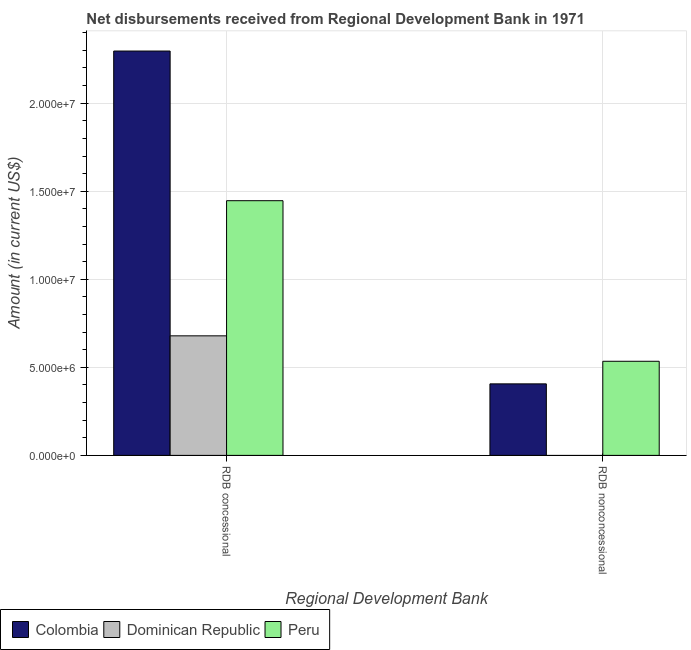How many groups of bars are there?
Your answer should be very brief. 2. Are the number of bars per tick equal to the number of legend labels?
Your answer should be compact. No. How many bars are there on the 2nd tick from the left?
Give a very brief answer. 2. What is the label of the 1st group of bars from the left?
Make the answer very short. RDB concessional. What is the net concessional disbursements from rdb in Peru?
Provide a succinct answer. 1.45e+07. Across all countries, what is the maximum net non concessional disbursements from rdb?
Make the answer very short. 5.34e+06. Across all countries, what is the minimum net non concessional disbursements from rdb?
Your answer should be compact. 0. What is the total net concessional disbursements from rdb in the graph?
Your response must be concise. 4.42e+07. What is the difference between the net concessional disbursements from rdb in Peru and that in Dominican Republic?
Your response must be concise. 7.68e+06. What is the difference between the net non concessional disbursements from rdb in Peru and the net concessional disbursements from rdb in Colombia?
Make the answer very short. -1.76e+07. What is the average net concessional disbursements from rdb per country?
Your response must be concise. 1.47e+07. What is the difference between the net non concessional disbursements from rdb and net concessional disbursements from rdb in Colombia?
Ensure brevity in your answer.  -1.89e+07. In how many countries, is the net non concessional disbursements from rdb greater than 7000000 US$?
Your response must be concise. 0. What is the ratio of the net concessional disbursements from rdb in Peru to that in Dominican Republic?
Provide a short and direct response. 2.13. Is the net concessional disbursements from rdb in Colombia less than that in Peru?
Ensure brevity in your answer.  No. In how many countries, is the net concessional disbursements from rdb greater than the average net concessional disbursements from rdb taken over all countries?
Your response must be concise. 1. How many bars are there?
Your response must be concise. 5. How many countries are there in the graph?
Provide a short and direct response. 3. What is the difference between two consecutive major ticks on the Y-axis?
Give a very brief answer. 5.00e+06. Does the graph contain any zero values?
Make the answer very short. Yes. Does the graph contain grids?
Offer a terse response. Yes. How many legend labels are there?
Offer a terse response. 3. What is the title of the graph?
Your answer should be very brief. Net disbursements received from Regional Development Bank in 1971. What is the label or title of the X-axis?
Provide a succinct answer. Regional Development Bank. What is the label or title of the Y-axis?
Provide a succinct answer. Amount (in current US$). What is the Amount (in current US$) in Colombia in RDB concessional?
Your answer should be very brief. 2.30e+07. What is the Amount (in current US$) in Dominican Republic in RDB concessional?
Your answer should be very brief. 6.79e+06. What is the Amount (in current US$) in Peru in RDB concessional?
Your answer should be very brief. 1.45e+07. What is the Amount (in current US$) in Colombia in RDB nonconcessional?
Keep it short and to the point. 4.06e+06. What is the Amount (in current US$) in Dominican Republic in RDB nonconcessional?
Provide a succinct answer. 0. What is the Amount (in current US$) of Peru in RDB nonconcessional?
Your answer should be very brief. 5.34e+06. Across all Regional Development Bank, what is the maximum Amount (in current US$) in Colombia?
Your answer should be very brief. 2.30e+07. Across all Regional Development Bank, what is the maximum Amount (in current US$) of Dominican Republic?
Keep it short and to the point. 6.79e+06. Across all Regional Development Bank, what is the maximum Amount (in current US$) of Peru?
Offer a very short reply. 1.45e+07. Across all Regional Development Bank, what is the minimum Amount (in current US$) of Colombia?
Ensure brevity in your answer.  4.06e+06. Across all Regional Development Bank, what is the minimum Amount (in current US$) in Peru?
Provide a succinct answer. 5.34e+06. What is the total Amount (in current US$) in Colombia in the graph?
Your response must be concise. 2.70e+07. What is the total Amount (in current US$) in Dominican Republic in the graph?
Make the answer very short. 6.79e+06. What is the total Amount (in current US$) in Peru in the graph?
Your answer should be very brief. 1.98e+07. What is the difference between the Amount (in current US$) in Colombia in RDB concessional and that in RDB nonconcessional?
Offer a very short reply. 1.89e+07. What is the difference between the Amount (in current US$) in Peru in RDB concessional and that in RDB nonconcessional?
Make the answer very short. 9.12e+06. What is the difference between the Amount (in current US$) in Colombia in RDB concessional and the Amount (in current US$) in Peru in RDB nonconcessional?
Offer a very short reply. 1.76e+07. What is the difference between the Amount (in current US$) in Dominican Republic in RDB concessional and the Amount (in current US$) in Peru in RDB nonconcessional?
Offer a very short reply. 1.44e+06. What is the average Amount (in current US$) in Colombia per Regional Development Bank?
Ensure brevity in your answer.  1.35e+07. What is the average Amount (in current US$) in Dominican Republic per Regional Development Bank?
Offer a very short reply. 3.39e+06. What is the average Amount (in current US$) in Peru per Regional Development Bank?
Ensure brevity in your answer.  9.90e+06. What is the difference between the Amount (in current US$) of Colombia and Amount (in current US$) of Dominican Republic in RDB concessional?
Offer a very short reply. 1.62e+07. What is the difference between the Amount (in current US$) of Colombia and Amount (in current US$) of Peru in RDB concessional?
Your answer should be very brief. 8.50e+06. What is the difference between the Amount (in current US$) of Dominican Republic and Amount (in current US$) of Peru in RDB concessional?
Your answer should be very brief. -7.68e+06. What is the difference between the Amount (in current US$) in Colombia and Amount (in current US$) in Peru in RDB nonconcessional?
Your answer should be very brief. -1.28e+06. What is the ratio of the Amount (in current US$) of Colombia in RDB concessional to that in RDB nonconcessional?
Offer a terse response. 5.65. What is the ratio of the Amount (in current US$) of Peru in RDB concessional to that in RDB nonconcessional?
Ensure brevity in your answer.  2.71. What is the difference between the highest and the second highest Amount (in current US$) of Colombia?
Offer a terse response. 1.89e+07. What is the difference between the highest and the second highest Amount (in current US$) of Peru?
Give a very brief answer. 9.12e+06. What is the difference between the highest and the lowest Amount (in current US$) in Colombia?
Provide a succinct answer. 1.89e+07. What is the difference between the highest and the lowest Amount (in current US$) in Dominican Republic?
Offer a terse response. 6.79e+06. What is the difference between the highest and the lowest Amount (in current US$) of Peru?
Provide a succinct answer. 9.12e+06. 